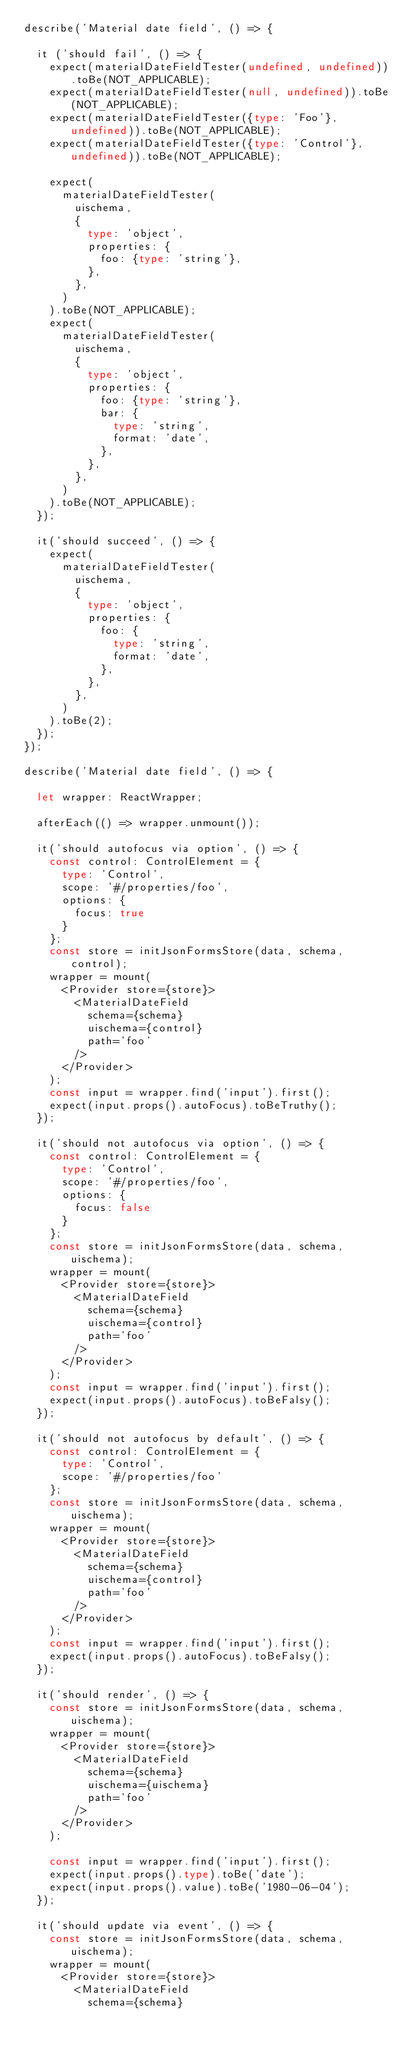<code> <loc_0><loc_0><loc_500><loc_500><_TypeScript_>describe('Material date field', () => {

  it ('should fail', () => {
    expect(materialDateFieldTester(undefined, undefined)).toBe(NOT_APPLICABLE);
    expect(materialDateFieldTester(null, undefined)).toBe(NOT_APPLICABLE);
    expect(materialDateFieldTester({type: 'Foo'}, undefined)).toBe(NOT_APPLICABLE);
    expect(materialDateFieldTester({type: 'Control'}, undefined)).toBe(NOT_APPLICABLE);

    expect(
      materialDateFieldTester(
        uischema,
        {
          type: 'object',
          properties: {
            foo: {type: 'string'},
          },
        },
      )
    ).toBe(NOT_APPLICABLE);
    expect(
      materialDateFieldTester(
        uischema,
        {
          type: 'object',
          properties: {
            foo: {type: 'string'},
            bar: {
              type: 'string',
              format: 'date',
            },
          },
        },
      )
    ).toBe(NOT_APPLICABLE);
  });

  it('should succeed', () => {
    expect(
      materialDateFieldTester(
        uischema,
        {
          type: 'object',
          properties: {
            foo: {
              type: 'string',
              format: 'date',
            },
          },
        },
      )
    ).toBe(2);
  });
});

describe('Material date field', () => {

  let wrapper: ReactWrapper;

  afterEach(() => wrapper.unmount());

  it('should autofocus via option', () => {
    const control: ControlElement = {
      type: 'Control',
      scope: '#/properties/foo',
      options: {
        focus: true
      }
    };
    const store = initJsonFormsStore(data, schema, control);
    wrapper = mount(
      <Provider store={store}>
        <MaterialDateField
          schema={schema}
          uischema={control}
          path='foo'
        />
      </Provider>
    );
    const input = wrapper.find('input').first();
    expect(input.props().autoFocus).toBeTruthy();
  });

  it('should not autofocus via option', () => {
    const control: ControlElement = {
      type: 'Control',
      scope: '#/properties/foo',
      options: {
        focus: false
      }
    };
    const store = initJsonFormsStore(data, schema, uischema);
    wrapper = mount(
      <Provider store={store}>
        <MaterialDateField
          schema={schema}
          uischema={control}
          path='foo'
        />
      </Provider>
    );
    const input = wrapper.find('input').first();
    expect(input.props().autoFocus).toBeFalsy();
  });

  it('should not autofocus by default', () => {
    const control: ControlElement = {
      type: 'Control',
      scope: '#/properties/foo'
    };
    const store = initJsonFormsStore(data, schema, uischema);
    wrapper = mount(
      <Provider store={store}>
        <MaterialDateField
          schema={schema}
          uischema={control}
          path='foo'
        />
      </Provider>
    );
    const input = wrapper.find('input').first();
    expect(input.props().autoFocus).toBeFalsy();
  });

  it('should render', () => {
    const store = initJsonFormsStore(data, schema, uischema);
    wrapper = mount(
      <Provider store={store}>
        <MaterialDateField
          schema={schema}
          uischema={uischema}
          path='foo'
        />
      </Provider>
    );

    const input = wrapper.find('input').first();
    expect(input.props().type).toBe('date');
    expect(input.props().value).toBe('1980-06-04');
  });

  it('should update via event', () => {
    const store = initJsonFormsStore(data, schema, uischema);
    wrapper = mount(
      <Provider store={store}>
        <MaterialDateField
          schema={schema}</code> 